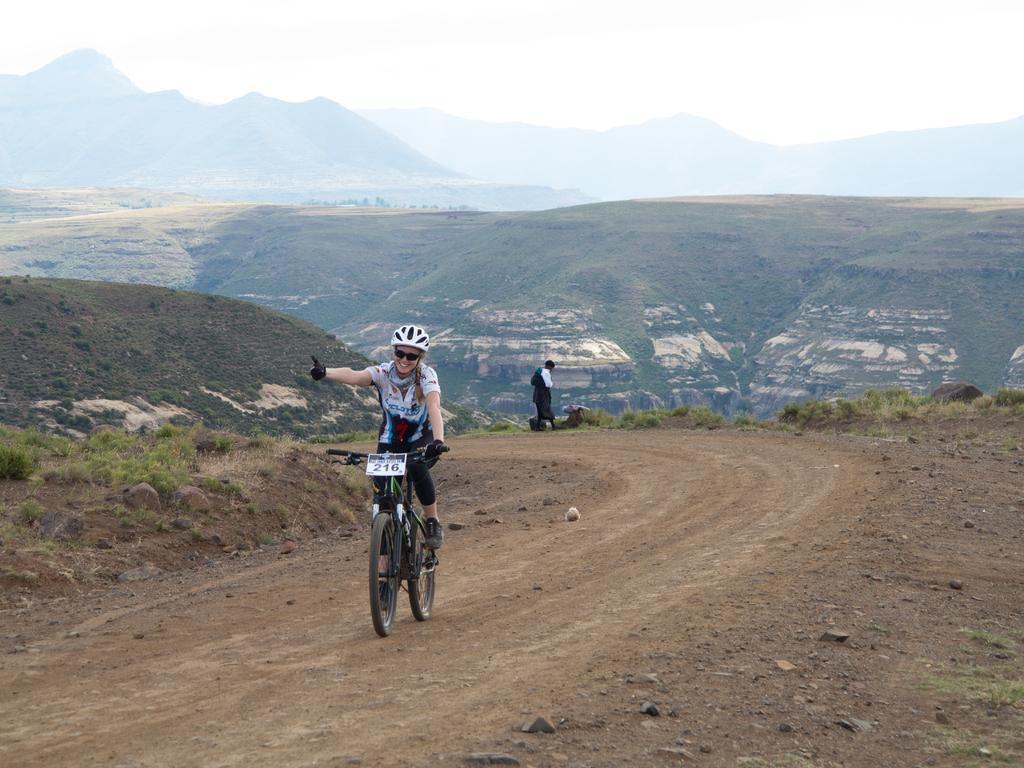Please provide a concise description of this image. In this picture we can see a person riding a bicycle on the road surrounded by greenery and mountains. 